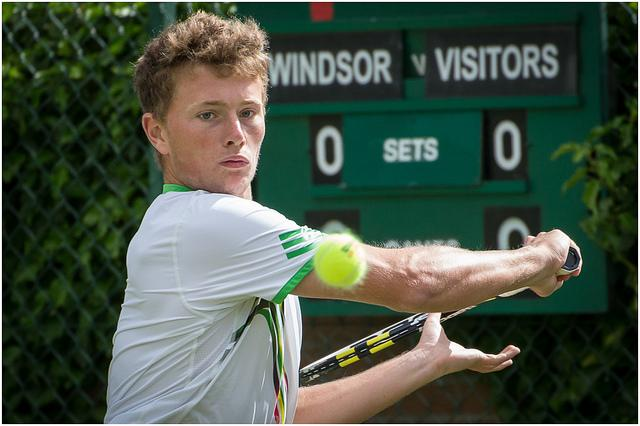Someone needs to score at least how many sets to win? two 